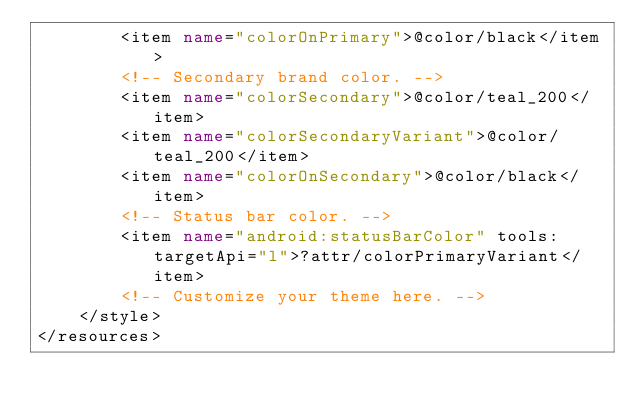Convert code to text. <code><loc_0><loc_0><loc_500><loc_500><_XML_>        <item name="colorOnPrimary">@color/black</item>
        <!-- Secondary brand color. -->
        <item name="colorSecondary">@color/teal_200</item>
        <item name="colorSecondaryVariant">@color/teal_200</item>
        <item name="colorOnSecondary">@color/black</item>
        <!-- Status bar color. -->
        <item name="android:statusBarColor" tools:targetApi="l">?attr/colorPrimaryVariant</item>
        <!-- Customize your theme here. -->
    </style>
</resources></code> 